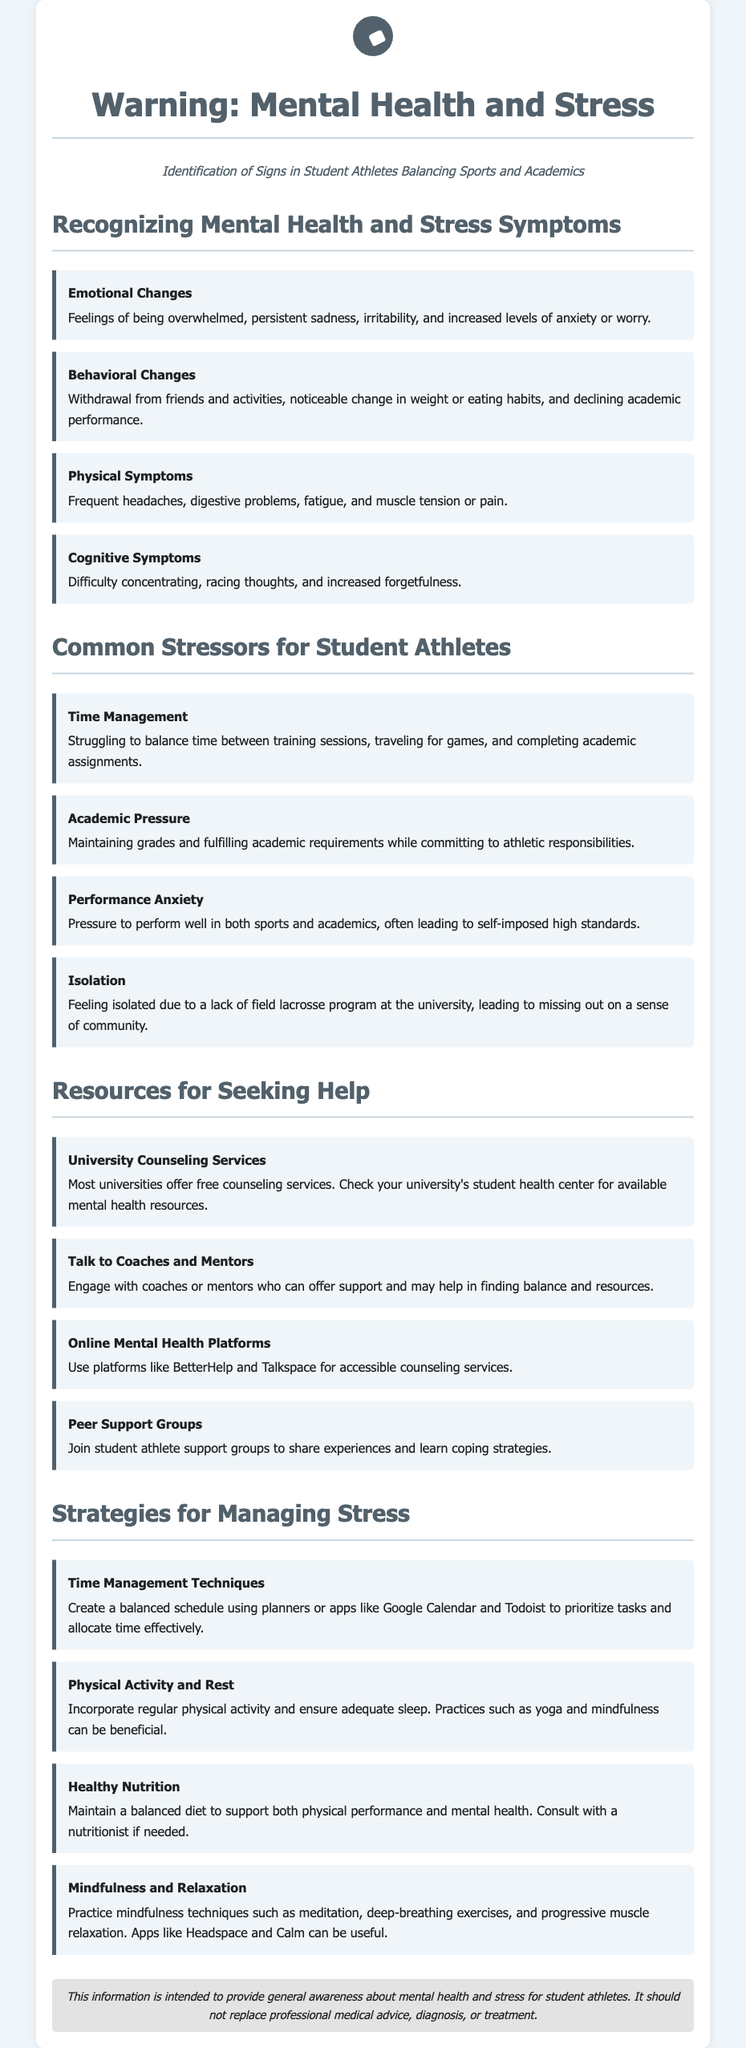What are emotional changes? Emotional changes are described as feelings of being overwhelmed, persistent sadness, irritability, and increased levels of anxiety or worry.
Answer: Feelings of being overwhelmed, persistent sadness, irritability, and increased levels of anxiety or worry What is one physical symptom of stress? One physical symptom of stress mentioned in the document is frequent headaches.
Answer: Frequent headaches What is the title of the document? The title of the document is the main heading presented at the top of the page.
Answer: Warning: Mental Health and Stress Which service can students contact for counseling? The document states that most universities offer free counseling services, which they can find at their student health center.
Answer: University Counseling Services What can peer support groups help with? Peer support groups can help students share experiences and learn coping strategies.
Answer: Share experiences and learn coping strategies What is one strategy for managing stress? One strategy mentioned for managing stress is to practice mindfulness techniques such as meditation.
Answer: Practice mindfulness techniques such as meditation What does isolation refer to in the context of student athletes? Isolation refers to feeling isolated due to a lack of field lacrosse program at the university, leading to missing out on a sense of community.
Answer: Feeling isolated due to a lack of field lacrosse program 